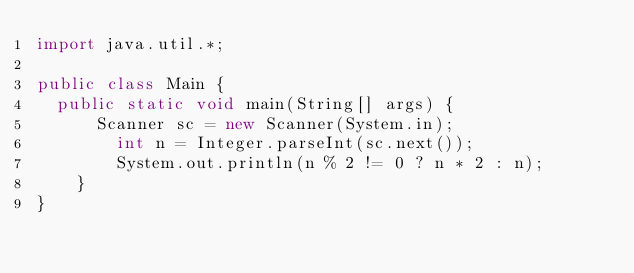Convert code to text. <code><loc_0><loc_0><loc_500><loc_500><_Java_>import java.util.*;
 
public class Main {
	public static void main(String[] args) {
    	Scanner sc = new Scanner(System.in);
        int n = Integer.parseInt(sc.next());
        System.out.println(n % 2 != 0 ? n * 2 : n);
    }
}</code> 